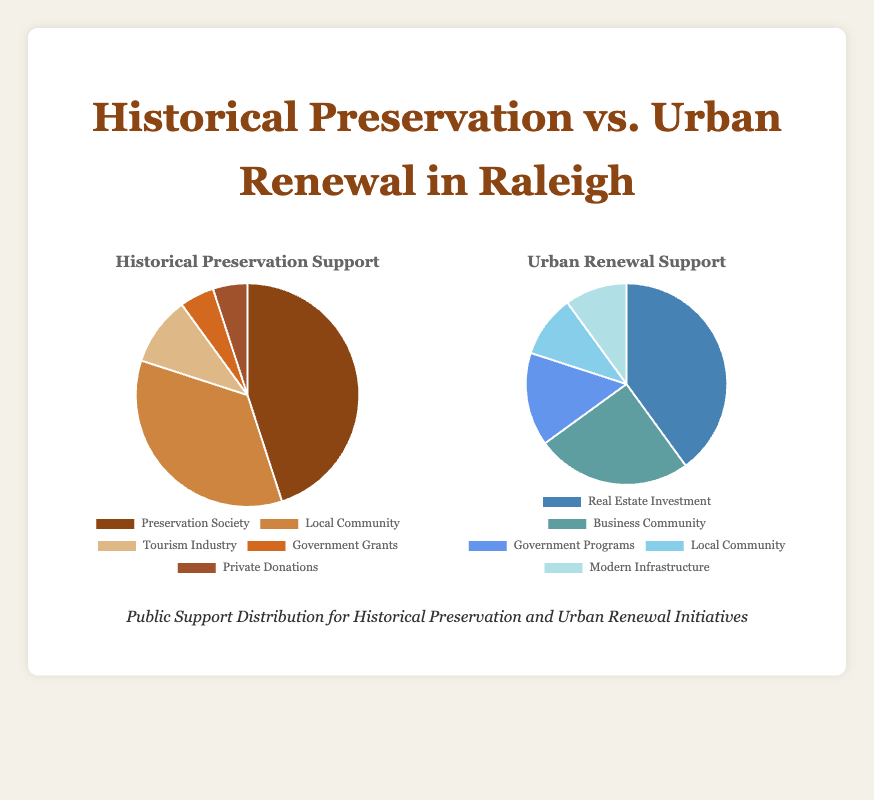What's the largest single source of support for Historical Preservation? By looking at the Historical Preservation support pie chart, the largest segment corresponds to the Preservation Society. The chart labels show that the Preservation Society's support is 45%.
Answer: Preservation Society Which initiative has more support from the local community between Historical Preservation and Urban Renewal? By comparing the segments labeled "Local Community" on both pie charts, the Historical Preservation chart shows 35% local community support and the Urban Renewal chart shows 10%.
Answer: Historical Preservation What is the combined support percentage for Tourism Industry and Private Donations in Historical Preservation? Add the support percentages for the Tourism Industry (10%) and Private Donations (5%). Total: 10 + 5 = 15%.
Answer: 15% Which visual segment in the Urban Renewal pie chart is the second largest? By examining the segments in the Urban Renewal pie chart, the Business Community segment is the second largest after Real Estate Investment, with a support of 25%.
Answer: Business Community What is the difference in the support percentage between Real Estate Investment in Urban Renewal and Preservation Society in Historical Preservation? Subtract the Preservation Society's support (45%) from the Real Estate Investment's support (40%). Difference: 45 - 40 = 5%.
Answer: 5% What is the percentage of support for Government Grants in Historical Preservation versus Government Development Programs in Urban Renewal? In the Historical Preservation pie chart, Government Grants have 5% support, while in Urban Renewal, Government Development Programs have 15%.
Answer: 5%, 15% What is the combined support of the Preservation Society and Local Community for Historical Preservation? Add the support percentages for the Preservation Society (45%) and Local Community (35%). Total: 45 + 35 = 80%.
Answer: 80% Which type of support contributes the least to Urban Renewal initiatives? By examining the smallest segment in the Urban Renewal pie chart, Local Community and Modern Infrastructure both contribute 10%.
Answer: Local Community, Modern Infrastructure 